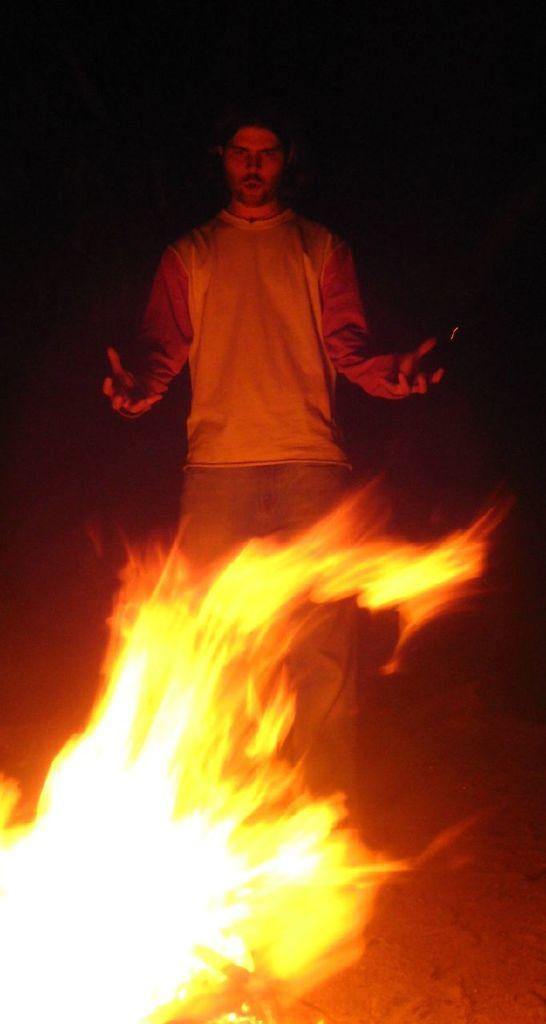What is the main subject of the image? There is a man standing in the image. What is the man wearing? The man is wearing clothes. What type of terrain can be seen in the image? There is sand in the image. What is the presence of fire in the image indicating? The presence of fire in the image suggests that there might be a campfire or a controlled fire. What type of hen can be seen holding hands with the man in the image? There is no hen or any indication of hands holding in the image. 